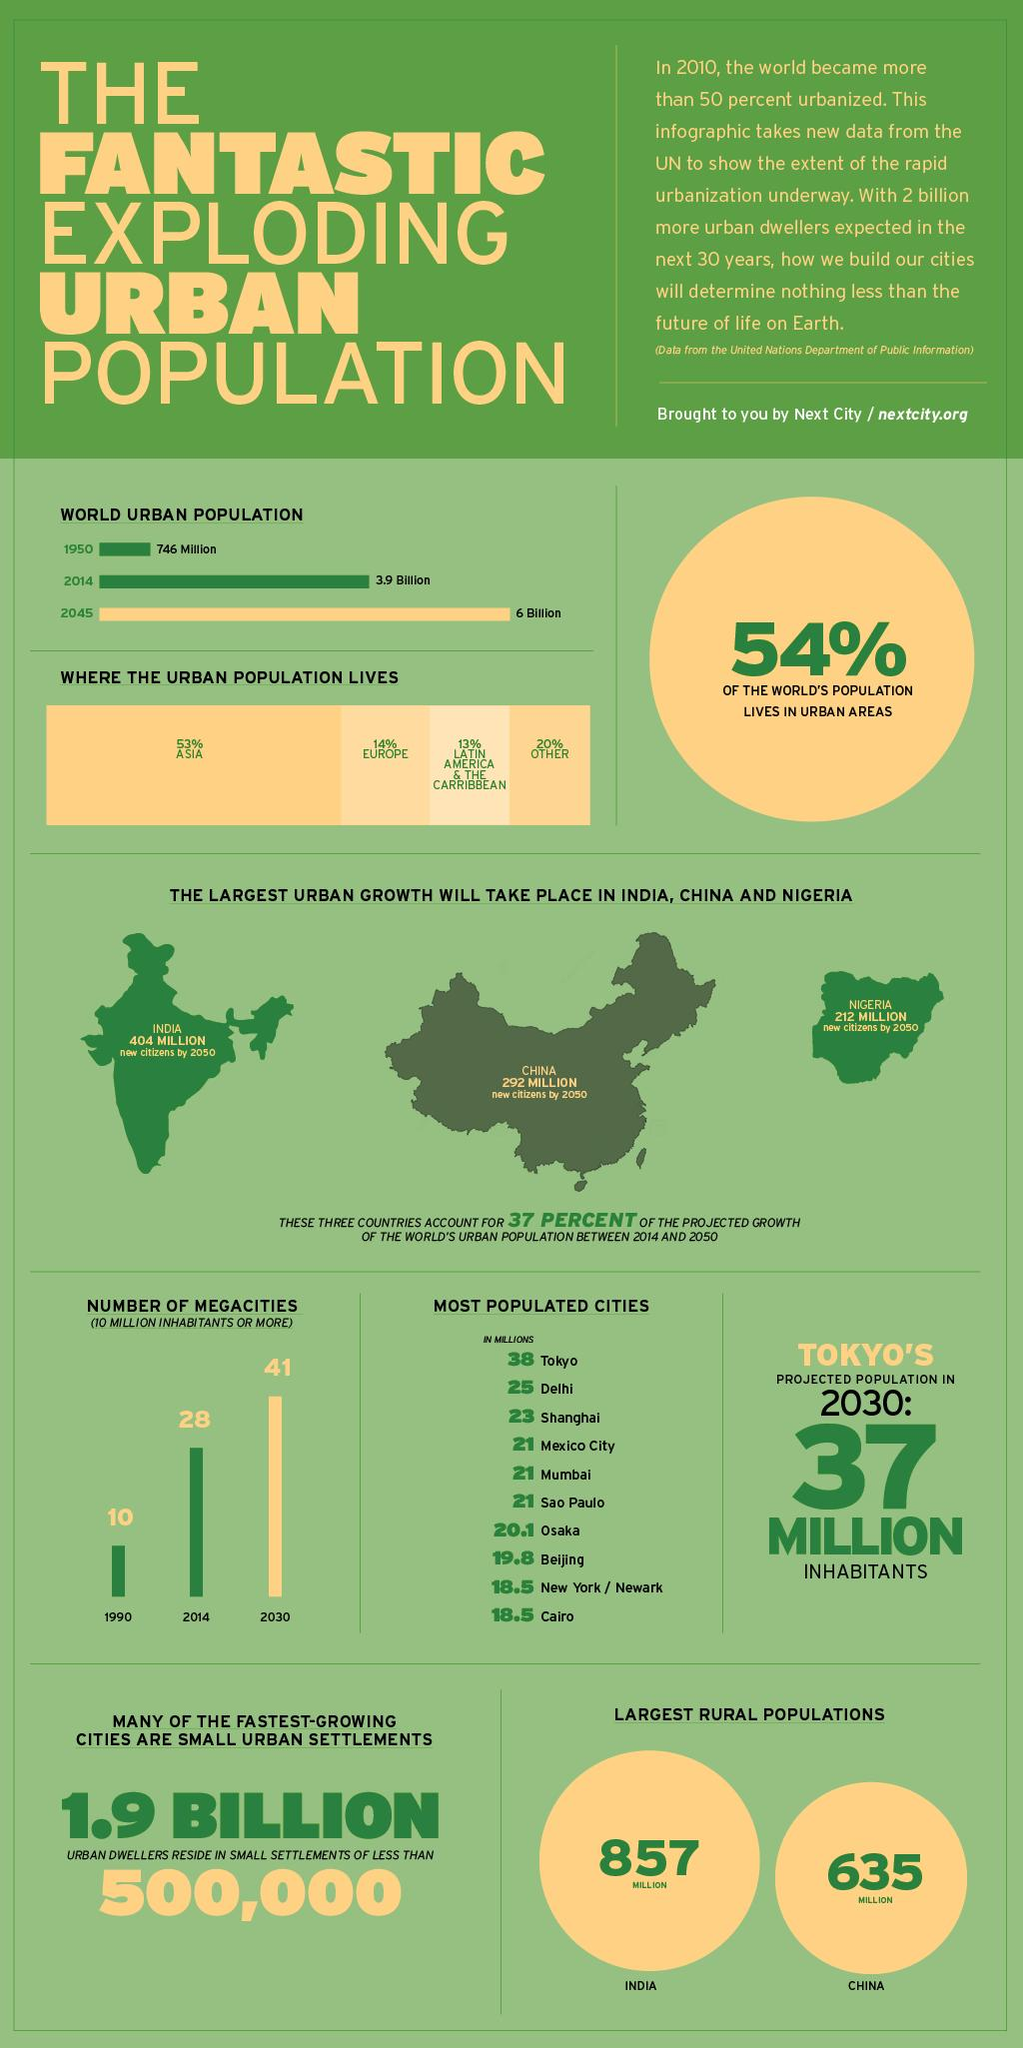Give some essential details in this illustration. In the year 2045, the population difference between 2014 and 2045 is expected to be approximately 2.1 billion. Mumbai has a population that is similar to that of Mexico City and Sao Paulo. India has a rural population of approximately 942 million, while China has a rural population of approximately 748 million, resulting in a difference of 222 million people. The population difference between Delhi and Mumbai is approximately 4 million. It is projected that by 2050, the total number of new citizens in India, China, and Nigeria will reach approximately 908 million. 